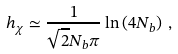<formula> <loc_0><loc_0><loc_500><loc_500>h _ { \chi } \simeq \frac { 1 } { \sqrt { 2 } N _ { b } \pi } \ln \left ( 4 N _ { b } \right ) \, ,</formula> 